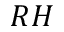<formula> <loc_0><loc_0><loc_500><loc_500>R H</formula> 